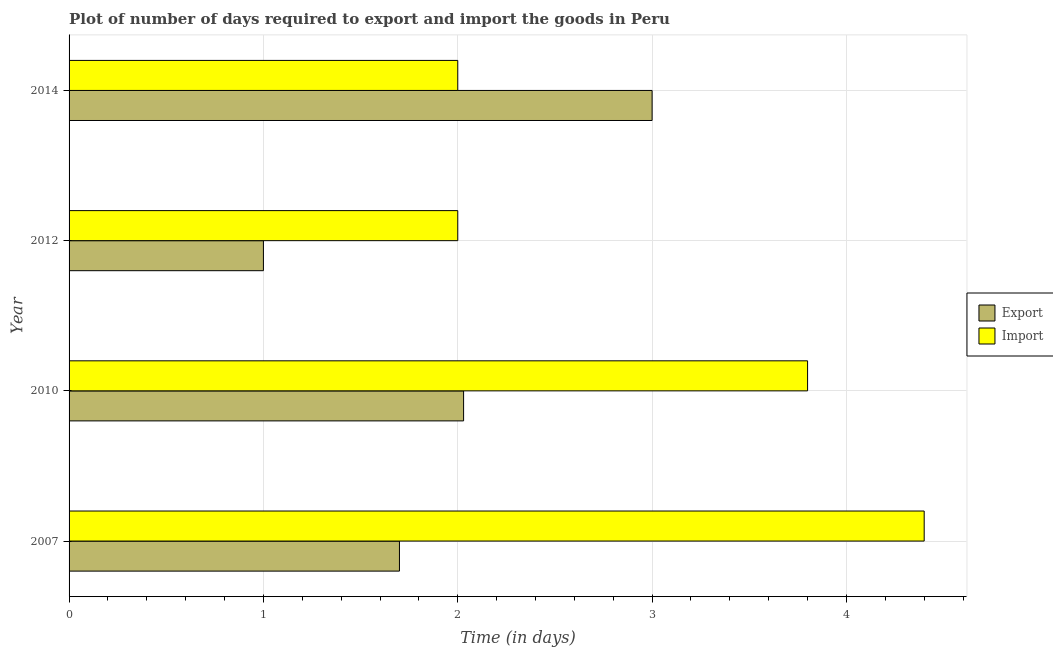How many groups of bars are there?
Your answer should be very brief. 4. Are the number of bars per tick equal to the number of legend labels?
Give a very brief answer. Yes. How many bars are there on the 4th tick from the bottom?
Make the answer very short. 2. Across all years, what is the maximum time required to import?
Keep it short and to the point. 4.4. Across all years, what is the minimum time required to import?
Your answer should be compact. 2. In which year was the time required to export minimum?
Give a very brief answer. 2012. What is the total time required to export in the graph?
Offer a terse response. 7.73. What is the average time required to export per year?
Ensure brevity in your answer.  1.93. In the year 2012, what is the difference between the time required to import and time required to export?
Keep it short and to the point. 1. What is the ratio of the time required to export in 2010 to that in 2014?
Keep it short and to the point. 0.68. Is the time required to import in 2010 less than that in 2012?
Keep it short and to the point. No. Is the difference between the time required to export in 2010 and 2014 greater than the difference between the time required to import in 2010 and 2014?
Ensure brevity in your answer.  No. What is the difference between the highest and the second highest time required to import?
Offer a terse response. 0.6. What is the difference between the highest and the lowest time required to export?
Make the answer very short. 2. Is the sum of the time required to export in 2007 and 2010 greater than the maximum time required to import across all years?
Provide a succinct answer. No. What does the 2nd bar from the top in 2007 represents?
Provide a succinct answer. Export. What does the 1st bar from the bottom in 2010 represents?
Give a very brief answer. Export. How many bars are there?
Your response must be concise. 8. How many years are there in the graph?
Your response must be concise. 4. Does the graph contain any zero values?
Your response must be concise. No. Where does the legend appear in the graph?
Make the answer very short. Center right. How many legend labels are there?
Your answer should be very brief. 2. What is the title of the graph?
Provide a succinct answer. Plot of number of days required to export and import the goods in Peru. Does "Constant 2005 US$" appear as one of the legend labels in the graph?
Keep it short and to the point. No. What is the label or title of the X-axis?
Provide a short and direct response. Time (in days). What is the label or title of the Y-axis?
Provide a succinct answer. Year. What is the Time (in days) in Export in 2007?
Keep it short and to the point. 1.7. What is the Time (in days) of Import in 2007?
Make the answer very short. 4.4. What is the Time (in days) of Export in 2010?
Ensure brevity in your answer.  2.03. What is the Time (in days) of Import in 2010?
Your answer should be very brief. 3.8. What is the Time (in days) of Export in 2012?
Give a very brief answer. 1. Across all years, what is the maximum Time (in days) of Export?
Your response must be concise. 3. What is the total Time (in days) in Export in the graph?
Offer a terse response. 7.73. What is the total Time (in days) of Import in the graph?
Provide a short and direct response. 12.2. What is the difference between the Time (in days) of Export in 2007 and that in 2010?
Your answer should be very brief. -0.33. What is the difference between the Time (in days) in Export in 2007 and that in 2012?
Offer a terse response. 0.7. What is the difference between the Time (in days) of Export in 2007 and that in 2014?
Keep it short and to the point. -1.3. What is the difference between the Time (in days) in Export in 2010 and that in 2012?
Keep it short and to the point. 1.03. What is the difference between the Time (in days) of Export in 2010 and that in 2014?
Give a very brief answer. -0.97. What is the difference between the Time (in days) in Export in 2012 and that in 2014?
Make the answer very short. -2. What is the difference between the Time (in days) of Export in 2007 and the Time (in days) of Import in 2010?
Provide a short and direct response. -2.1. What is the difference between the Time (in days) in Export in 2007 and the Time (in days) in Import in 2014?
Offer a terse response. -0.3. What is the average Time (in days) of Export per year?
Offer a very short reply. 1.93. What is the average Time (in days) in Import per year?
Give a very brief answer. 3.05. In the year 2010, what is the difference between the Time (in days) of Export and Time (in days) of Import?
Keep it short and to the point. -1.77. In the year 2014, what is the difference between the Time (in days) of Export and Time (in days) of Import?
Make the answer very short. 1. What is the ratio of the Time (in days) in Export in 2007 to that in 2010?
Your answer should be compact. 0.84. What is the ratio of the Time (in days) in Import in 2007 to that in 2010?
Offer a terse response. 1.16. What is the ratio of the Time (in days) of Export in 2007 to that in 2012?
Offer a very short reply. 1.7. What is the ratio of the Time (in days) in Export in 2007 to that in 2014?
Offer a very short reply. 0.57. What is the ratio of the Time (in days) in Import in 2007 to that in 2014?
Offer a terse response. 2.2. What is the ratio of the Time (in days) of Export in 2010 to that in 2012?
Offer a very short reply. 2.03. What is the ratio of the Time (in days) in Export in 2010 to that in 2014?
Your answer should be very brief. 0.68. What is the ratio of the Time (in days) in Import in 2010 to that in 2014?
Offer a very short reply. 1.9. What is the ratio of the Time (in days) in Import in 2012 to that in 2014?
Your response must be concise. 1. What is the difference between the highest and the lowest Time (in days) in Export?
Your answer should be very brief. 2. What is the difference between the highest and the lowest Time (in days) in Import?
Give a very brief answer. 2.4. 